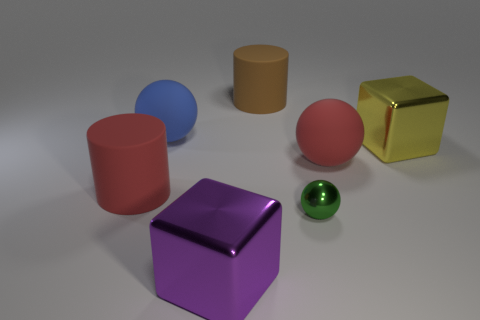There is a purple thing; is its shape the same as the object that is behind the blue matte thing?
Keep it short and to the point. No. What number of blue matte objects have the same size as the red matte cylinder?
Provide a short and direct response. 1. There is a big matte ball in front of the blue ball that is behind the yellow shiny block; how many large yellow metal blocks are to the right of it?
Your answer should be very brief. 1. Is the number of brown rubber objects behind the brown thing the same as the number of big brown objects behind the big purple shiny thing?
Offer a terse response. No. How many tiny gray things are the same shape as the blue matte object?
Your answer should be compact. 0. Is there another red ball that has the same material as the large red ball?
Ensure brevity in your answer.  No. What number of green objects are there?
Your response must be concise. 1. What number of spheres are green things or matte objects?
Your answer should be compact. 3. What is the color of the cylinder that is the same size as the brown matte thing?
Your answer should be very brief. Red. How many large objects are both behind the big red cylinder and in front of the big blue object?
Offer a very short reply. 2. 